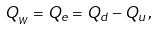Convert formula to latex. <formula><loc_0><loc_0><loc_500><loc_500>Q _ { _ { W } } = Q _ { e } = Q _ { d } - Q _ { u } \, ,</formula> 